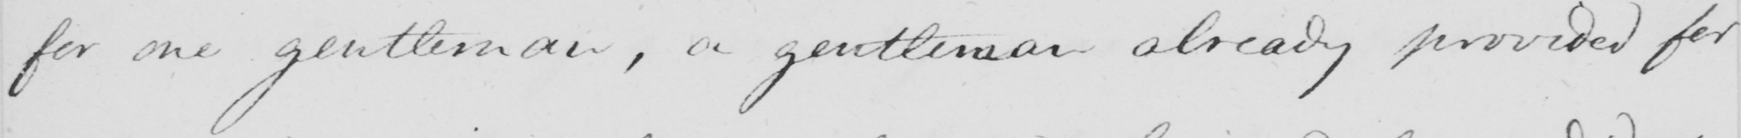What does this handwritten line say? for one gentleman , a gentleman already provided for 